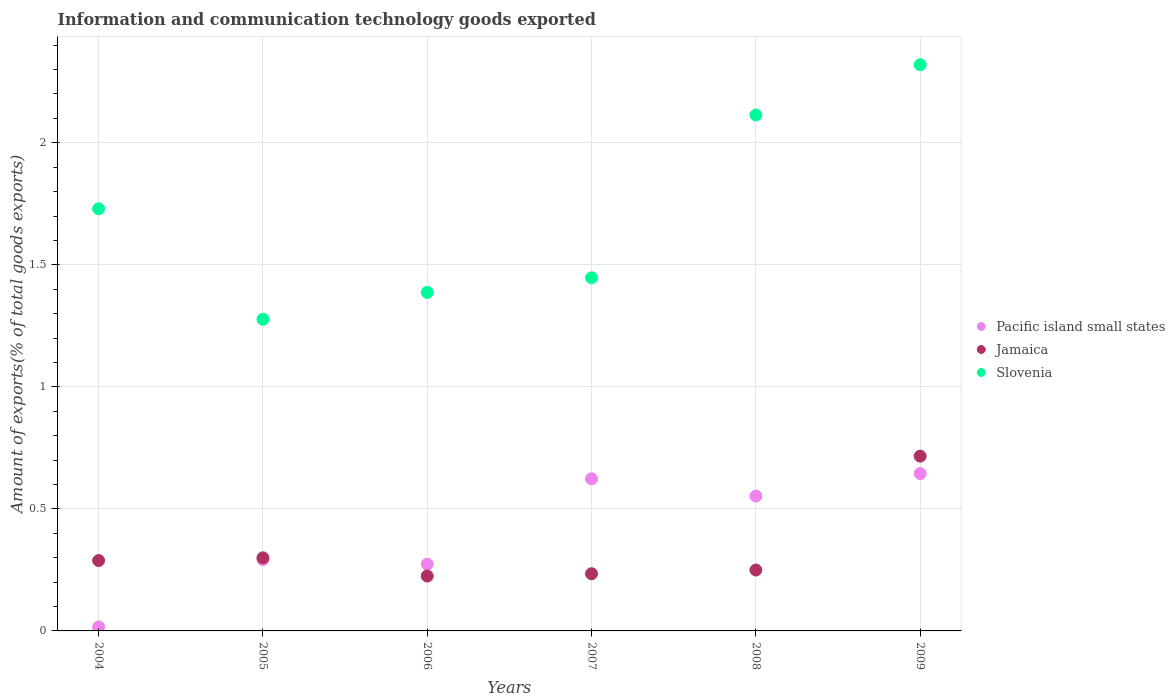What is the amount of goods exported in Pacific island small states in 2007?
Provide a short and direct response. 0.62. Across all years, what is the maximum amount of goods exported in Slovenia?
Offer a very short reply. 2.32. Across all years, what is the minimum amount of goods exported in Pacific island small states?
Ensure brevity in your answer.  0.02. What is the total amount of goods exported in Slovenia in the graph?
Your answer should be very brief. 10.27. What is the difference between the amount of goods exported in Pacific island small states in 2005 and that in 2008?
Ensure brevity in your answer.  -0.26. What is the difference between the amount of goods exported in Slovenia in 2006 and the amount of goods exported in Jamaica in 2004?
Your response must be concise. 1.1. What is the average amount of goods exported in Slovenia per year?
Ensure brevity in your answer.  1.71. In the year 2004, what is the difference between the amount of goods exported in Pacific island small states and amount of goods exported in Slovenia?
Offer a very short reply. -1.71. In how many years, is the amount of goods exported in Pacific island small states greater than 0.9 %?
Your response must be concise. 0. What is the ratio of the amount of goods exported in Slovenia in 2007 to that in 2009?
Provide a short and direct response. 0.62. What is the difference between the highest and the second highest amount of goods exported in Slovenia?
Offer a terse response. 0.21. What is the difference between the highest and the lowest amount of goods exported in Pacific island small states?
Provide a succinct answer. 0.63. In how many years, is the amount of goods exported in Slovenia greater than the average amount of goods exported in Slovenia taken over all years?
Keep it short and to the point. 3. Is the amount of goods exported in Slovenia strictly greater than the amount of goods exported in Pacific island small states over the years?
Offer a very short reply. Yes. Is the amount of goods exported in Jamaica strictly less than the amount of goods exported in Slovenia over the years?
Offer a terse response. Yes. How many dotlines are there?
Make the answer very short. 3. How many years are there in the graph?
Provide a short and direct response. 6. What is the difference between two consecutive major ticks on the Y-axis?
Offer a terse response. 0.5. Are the values on the major ticks of Y-axis written in scientific E-notation?
Your response must be concise. No. What is the title of the graph?
Keep it short and to the point. Information and communication technology goods exported. What is the label or title of the X-axis?
Provide a succinct answer. Years. What is the label or title of the Y-axis?
Provide a short and direct response. Amount of exports(% of total goods exports). What is the Amount of exports(% of total goods exports) of Pacific island small states in 2004?
Your answer should be very brief. 0.02. What is the Amount of exports(% of total goods exports) in Jamaica in 2004?
Keep it short and to the point. 0.29. What is the Amount of exports(% of total goods exports) of Slovenia in 2004?
Your answer should be compact. 1.73. What is the Amount of exports(% of total goods exports) in Pacific island small states in 2005?
Ensure brevity in your answer.  0.29. What is the Amount of exports(% of total goods exports) of Jamaica in 2005?
Give a very brief answer. 0.3. What is the Amount of exports(% of total goods exports) of Slovenia in 2005?
Provide a succinct answer. 1.28. What is the Amount of exports(% of total goods exports) of Pacific island small states in 2006?
Give a very brief answer. 0.27. What is the Amount of exports(% of total goods exports) of Jamaica in 2006?
Offer a terse response. 0.22. What is the Amount of exports(% of total goods exports) of Slovenia in 2006?
Make the answer very short. 1.39. What is the Amount of exports(% of total goods exports) of Pacific island small states in 2007?
Provide a short and direct response. 0.62. What is the Amount of exports(% of total goods exports) in Jamaica in 2007?
Ensure brevity in your answer.  0.23. What is the Amount of exports(% of total goods exports) in Slovenia in 2007?
Your answer should be compact. 1.45. What is the Amount of exports(% of total goods exports) in Pacific island small states in 2008?
Offer a very short reply. 0.55. What is the Amount of exports(% of total goods exports) in Jamaica in 2008?
Provide a short and direct response. 0.25. What is the Amount of exports(% of total goods exports) in Slovenia in 2008?
Offer a very short reply. 2.11. What is the Amount of exports(% of total goods exports) of Pacific island small states in 2009?
Offer a very short reply. 0.64. What is the Amount of exports(% of total goods exports) in Jamaica in 2009?
Give a very brief answer. 0.72. What is the Amount of exports(% of total goods exports) in Slovenia in 2009?
Provide a short and direct response. 2.32. Across all years, what is the maximum Amount of exports(% of total goods exports) of Pacific island small states?
Offer a terse response. 0.64. Across all years, what is the maximum Amount of exports(% of total goods exports) in Jamaica?
Offer a very short reply. 0.72. Across all years, what is the maximum Amount of exports(% of total goods exports) in Slovenia?
Your answer should be compact. 2.32. Across all years, what is the minimum Amount of exports(% of total goods exports) in Pacific island small states?
Offer a terse response. 0.02. Across all years, what is the minimum Amount of exports(% of total goods exports) of Jamaica?
Offer a very short reply. 0.22. Across all years, what is the minimum Amount of exports(% of total goods exports) of Slovenia?
Offer a terse response. 1.28. What is the total Amount of exports(% of total goods exports) of Pacific island small states in the graph?
Keep it short and to the point. 2.4. What is the total Amount of exports(% of total goods exports) of Jamaica in the graph?
Provide a succinct answer. 2.01. What is the total Amount of exports(% of total goods exports) of Slovenia in the graph?
Offer a very short reply. 10.27. What is the difference between the Amount of exports(% of total goods exports) in Pacific island small states in 2004 and that in 2005?
Make the answer very short. -0.28. What is the difference between the Amount of exports(% of total goods exports) of Jamaica in 2004 and that in 2005?
Make the answer very short. -0.01. What is the difference between the Amount of exports(% of total goods exports) in Slovenia in 2004 and that in 2005?
Ensure brevity in your answer.  0.45. What is the difference between the Amount of exports(% of total goods exports) in Pacific island small states in 2004 and that in 2006?
Your response must be concise. -0.26. What is the difference between the Amount of exports(% of total goods exports) of Jamaica in 2004 and that in 2006?
Offer a terse response. 0.06. What is the difference between the Amount of exports(% of total goods exports) of Slovenia in 2004 and that in 2006?
Offer a terse response. 0.34. What is the difference between the Amount of exports(% of total goods exports) of Pacific island small states in 2004 and that in 2007?
Your response must be concise. -0.61. What is the difference between the Amount of exports(% of total goods exports) of Jamaica in 2004 and that in 2007?
Offer a terse response. 0.05. What is the difference between the Amount of exports(% of total goods exports) of Slovenia in 2004 and that in 2007?
Provide a succinct answer. 0.28. What is the difference between the Amount of exports(% of total goods exports) of Pacific island small states in 2004 and that in 2008?
Give a very brief answer. -0.54. What is the difference between the Amount of exports(% of total goods exports) in Jamaica in 2004 and that in 2008?
Your answer should be very brief. 0.04. What is the difference between the Amount of exports(% of total goods exports) in Slovenia in 2004 and that in 2008?
Provide a short and direct response. -0.38. What is the difference between the Amount of exports(% of total goods exports) of Pacific island small states in 2004 and that in 2009?
Keep it short and to the point. -0.63. What is the difference between the Amount of exports(% of total goods exports) in Jamaica in 2004 and that in 2009?
Keep it short and to the point. -0.43. What is the difference between the Amount of exports(% of total goods exports) of Slovenia in 2004 and that in 2009?
Offer a terse response. -0.59. What is the difference between the Amount of exports(% of total goods exports) in Pacific island small states in 2005 and that in 2006?
Make the answer very short. 0.02. What is the difference between the Amount of exports(% of total goods exports) of Jamaica in 2005 and that in 2006?
Ensure brevity in your answer.  0.07. What is the difference between the Amount of exports(% of total goods exports) of Slovenia in 2005 and that in 2006?
Your answer should be compact. -0.11. What is the difference between the Amount of exports(% of total goods exports) in Pacific island small states in 2005 and that in 2007?
Keep it short and to the point. -0.33. What is the difference between the Amount of exports(% of total goods exports) in Jamaica in 2005 and that in 2007?
Ensure brevity in your answer.  0.07. What is the difference between the Amount of exports(% of total goods exports) in Slovenia in 2005 and that in 2007?
Provide a short and direct response. -0.17. What is the difference between the Amount of exports(% of total goods exports) of Pacific island small states in 2005 and that in 2008?
Your answer should be compact. -0.26. What is the difference between the Amount of exports(% of total goods exports) of Slovenia in 2005 and that in 2008?
Make the answer very short. -0.84. What is the difference between the Amount of exports(% of total goods exports) of Pacific island small states in 2005 and that in 2009?
Provide a short and direct response. -0.35. What is the difference between the Amount of exports(% of total goods exports) of Jamaica in 2005 and that in 2009?
Make the answer very short. -0.42. What is the difference between the Amount of exports(% of total goods exports) of Slovenia in 2005 and that in 2009?
Offer a very short reply. -1.04. What is the difference between the Amount of exports(% of total goods exports) in Pacific island small states in 2006 and that in 2007?
Provide a succinct answer. -0.35. What is the difference between the Amount of exports(% of total goods exports) in Jamaica in 2006 and that in 2007?
Make the answer very short. -0.01. What is the difference between the Amount of exports(% of total goods exports) of Slovenia in 2006 and that in 2007?
Your answer should be very brief. -0.06. What is the difference between the Amount of exports(% of total goods exports) in Pacific island small states in 2006 and that in 2008?
Your response must be concise. -0.28. What is the difference between the Amount of exports(% of total goods exports) in Jamaica in 2006 and that in 2008?
Keep it short and to the point. -0.02. What is the difference between the Amount of exports(% of total goods exports) of Slovenia in 2006 and that in 2008?
Ensure brevity in your answer.  -0.73. What is the difference between the Amount of exports(% of total goods exports) in Pacific island small states in 2006 and that in 2009?
Make the answer very short. -0.37. What is the difference between the Amount of exports(% of total goods exports) of Jamaica in 2006 and that in 2009?
Provide a succinct answer. -0.49. What is the difference between the Amount of exports(% of total goods exports) in Slovenia in 2006 and that in 2009?
Ensure brevity in your answer.  -0.93. What is the difference between the Amount of exports(% of total goods exports) of Pacific island small states in 2007 and that in 2008?
Provide a short and direct response. 0.07. What is the difference between the Amount of exports(% of total goods exports) in Jamaica in 2007 and that in 2008?
Make the answer very short. -0.02. What is the difference between the Amount of exports(% of total goods exports) in Slovenia in 2007 and that in 2008?
Your answer should be compact. -0.67. What is the difference between the Amount of exports(% of total goods exports) in Pacific island small states in 2007 and that in 2009?
Your answer should be compact. -0.02. What is the difference between the Amount of exports(% of total goods exports) of Jamaica in 2007 and that in 2009?
Make the answer very short. -0.48. What is the difference between the Amount of exports(% of total goods exports) in Slovenia in 2007 and that in 2009?
Make the answer very short. -0.87. What is the difference between the Amount of exports(% of total goods exports) of Pacific island small states in 2008 and that in 2009?
Make the answer very short. -0.09. What is the difference between the Amount of exports(% of total goods exports) of Jamaica in 2008 and that in 2009?
Keep it short and to the point. -0.47. What is the difference between the Amount of exports(% of total goods exports) in Slovenia in 2008 and that in 2009?
Keep it short and to the point. -0.21. What is the difference between the Amount of exports(% of total goods exports) in Pacific island small states in 2004 and the Amount of exports(% of total goods exports) in Jamaica in 2005?
Ensure brevity in your answer.  -0.28. What is the difference between the Amount of exports(% of total goods exports) of Pacific island small states in 2004 and the Amount of exports(% of total goods exports) of Slovenia in 2005?
Provide a short and direct response. -1.26. What is the difference between the Amount of exports(% of total goods exports) in Jamaica in 2004 and the Amount of exports(% of total goods exports) in Slovenia in 2005?
Offer a terse response. -0.99. What is the difference between the Amount of exports(% of total goods exports) of Pacific island small states in 2004 and the Amount of exports(% of total goods exports) of Jamaica in 2006?
Your answer should be compact. -0.21. What is the difference between the Amount of exports(% of total goods exports) in Pacific island small states in 2004 and the Amount of exports(% of total goods exports) in Slovenia in 2006?
Provide a succinct answer. -1.37. What is the difference between the Amount of exports(% of total goods exports) of Jamaica in 2004 and the Amount of exports(% of total goods exports) of Slovenia in 2006?
Offer a very short reply. -1.1. What is the difference between the Amount of exports(% of total goods exports) in Pacific island small states in 2004 and the Amount of exports(% of total goods exports) in Jamaica in 2007?
Your answer should be very brief. -0.22. What is the difference between the Amount of exports(% of total goods exports) in Pacific island small states in 2004 and the Amount of exports(% of total goods exports) in Slovenia in 2007?
Make the answer very short. -1.43. What is the difference between the Amount of exports(% of total goods exports) in Jamaica in 2004 and the Amount of exports(% of total goods exports) in Slovenia in 2007?
Keep it short and to the point. -1.16. What is the difference between the Amount of exports(% of total goods exports) in Pacific island small states in 2004 and the Amount of exports(% of total goods exports) in Jamaica in 2008?
Your response must be concise. -0.23. What is the difference between the Amount of exports(% of total goods exports) in Pacific island small states in 2004 and the Amount of exports(% of total goods exports) in Slovenia in 2008?
Your response must be concise. -2.1. What is the difference between the Amount of exports(% of total goods exports) in Jamaica in 2004 and the Amount of exports(% of total goods exports) in Slovenia in 2008?
Make the answer very short. -1.83. What is the difference between the Amount of exports(% of total goods exports) of Pacific island small states in 2004 and the Amount of exports(% of total goods exports) of Slovenia in 2009?
Your response must be concise. -2.3. What is the difference between the Amount of exports(% of total goods exports) of Jamaica in 2004 and the Amount of exports(% of total goods exports) of Slovenia in 2009?
Ensure brevity in your answer.  -2.03. What is the difference between the Amount of exports(% of total goods exports) of Pacific island small states in 2005 and the Amount of exports(% of total goods exports) of Jamaica in 2006?
Ensure brevity in your answer.  0.07. What is the difference between the Amount of exports(% of total goods exports) of Pacific island small states in 2005 and the Amount of exports(% of total goods exports) of Slovenia in 2006?
Provide a short and direct response. -1.09. What is the difference between the Amount of exports(% of total goods exports) of Jamaica in 2005 and the Amount of exports(% of total goods exports) of Slovenia in 2006?
Provide a short and direct response. -1.09. What is the difference between the Amount of exports(% of total goods exports) of Pacific island small states in 2005 and the Amount of exports(% of total goods exports) of Jamaica in 2007?
Your answer should be very brief. 0.06. What is the difference between the Amount of exports(% of total goods exports) of Pacific island small states in 2005 and the Amount of exports(% of total goods exports) of Slovenia in 2007?
Offer a very short reply. -1.15. What is the difference between the Amount of exports(% of total goods exports) of Jamaica in 2005 and the Amount of exports(% of total goods exports) of Slovenia in 2007?
Make the answer very short. -1.15. What is the difference between the Amount of exports(% of total goods exports) in Pacific island small states in 2005 and the Amount of exports(% of total goods exports) in Jamaica in 2008?
Offer a terse response. 0.04. What is the difference between the Amount of exports(% of total goods exports) of Pacific island small states in 2005 and the Amount of exports(% of total goods exports) of Slovenia in 2008?
Your answer should be compact. -1.82. What is the difference between the Amount of exports(% of total goods exports) in Jamaica in 2005 and the Amount of exports(% of total goods exports) in Slovenia in 2008?
Your answer should be compact. -1.81. What is the difference between the Amount of exports(% of total goods exports) of Pacific island small states in 2005 and the Amount of exports(% of total goods exports) of Jamaica in 2009?
Your response must be concise. -0.42. What is the difference between the Amount of exports(% of total goods exports) of Pacific island small states in 2005 and the Amount of exports(% of total goods exports) of Slovenia in 2009?
Keep it short and to the point. -2.03. What is the difference between the Amount of exports(% of total goods exports) in Jamaica in 2005 and the Amount of exports(% of total goods exports) in Slovenia in 2009?
Your answer should be very brief. -2.02. What is the difference between the Amount of exports(% of total goods exports) of Pacific island small states in 2006 and the Amount of exports(% of total goods exports) of Jamaica in 2007?
Your response must be concise. 0.04. What is the difference between the Amount of exports(% of total goods exports) of Pacific island small states in 2006 and the Amount of exports(% of total goods exports) of Slovenia in 2007?
Provide a succinct answer. -1.17. What is the difference between the Amount of exports(% of total goods exports) of Jamaica in 2006 and the Amount of exports(% of total goods exports) of Slovenia in 2007?
Offer a terse response. -1.22. What is the difference between the Amount of exports(% of total goods exports) in Pacific island small states in 2006 and the Amount of exports(% of total goods exports) in Jamaica in 2008?
Offer a terse response. 0.02. What is the difference between the Amount of exports(% of total goods exports) of Pacific island small states in 2006 and the Amount of exports(% of total goods exports) of Slovenia in 2008?
Offer a very short reply. -1.84. What is the difference between the Amount of exports(% of total goods exports) of Jamaica in 2006 and the Amount of exports(% of total goods exports) of Slovenia in 2008?
Give a very brief answer. -1.89. What is the difference between the Amount of exports(% of total goods exports) of Pacific island small states in 2006 and the Amount of exports(% of total goods exports) of Jamaica in 2009?
Your answer should be very brief. -0.44. What is the difference between the Amount of exports(% of total goods exports) of Pacific island small states in 2006 and the Amount of exports(% of total goods exports) of Slovenia in 2009?
Provide a succinct answer. -2.05. What is the difference between the Amount of exports(% of total goods exports) of Jamaica in 2006 and the Amount of exports(% of total goods exports) of Slovenia in 2009?
Provide a short and direct response. -2.1. What is the difference between the Amount of exports(% of total goods exports) in Pacific island small states in 2007 and the Amount of exports(% of total goods exports) in Jamaica in 2008?
Give a very brief answer. 0.37. What is the difference between the Amount of exports(% of total goods exports) of Pacific island small states in 2007 and the Amount of exports(% of total goods exports) of Slovenia in 2008?
Provide a succinct answer. -1.49. What is the difference between the Amount of exports(% of total goods exports) of Jamaica in 2007 and the Amount of exports(% of total goods exports) of Slovenia in 2008?
Provide a short and direct response. -1.88. What is the difference between the Amount of exports(% of total goods exports) of Pacific island small states in 2007 and the Amount of exports(% of total goods exports) of Jamaica in 2009?
Offer a terse response. -0.09. What is the difference between the Amount of exports(% of total goods exports) of Pacific island small states in 2007 and the Amount of exports(% of total goods exports) of Slovenia in 2009?
Keep it short and to the point. -1.7. What is the difference between the Amount of exports(% of total goods exports) of Jamaica in 2007 and the Amount of exports(% of total goods exports) of Slovenia in 2009?
Your answer should be very brief. -2.09. What is the difference between the Amount of exports(% of total goods exports) in Pacific island small states in 2008 and the Amount of exports(% of total goods exports) in Jamaica in 2009?
Your answer should be compact. -0.16. What is the difference between the Amount of exports(% of total goods exports) of Pacific island small states in 2008 and the Amount of exports(% of total goods exports) of Slovenia in 2009?
Your response must be concise. -1.77. What is the difference between the Amount of exports(% of total goods exports) of Jamaica in 2008 and the Amount of exports(% of total goods exports) of Slovenia in 2009?
Offer a very short reply. -2.07. What is the average Amount of exports(% of total goods exports) of Pacific island small states per year?
Make the answer very short. 0.4. What is the average Amount of exports(% of total goods exports) of Jamaica per year?
Offer a very short reply. 0.34. What is the average Amount of exports(% of total goods exports) of Slovenia per year?
Offer a very short reply. 1.71. In the year 2004, what is the difference between the Amount of exports(% of total goods exports) in Pacific island small states and Amount of exports(% of total goods exports) in Jamaica?
Make the answer very short. -0.27. In the year 2004, what is the difference between the Amount of exports(% of total goods exports) in Pacific island small states and Amount of exports(% of total goods exports) in Slovenia?
Give a very brief answer. -1.71. In the year 2004, what is the difference between the Amount of exports(% of total goods exports) in Jamaica and Amount of exports(% of total goods exports) in Slovenia?
Ensure brevity in your answer.  -1.44. In the year 2005, what is the difference between the Amount of exports(% of total goods exports) of Pacific island small states and Amount of exports(% of total goods exports) of Jamaica?
Keep it short and to the point. -0.01. In the year 2005, what is the difference between the Amount of exports(% of total goods exports) in Pacific island small states and Amount of exports(% of total goods exports) in Slovenia?
Offer a very short reply. -0.98. In the year 2005, what is the difference between the Amount of exports(% of total goods exports) in Jamaica and Amount of exports(% of total goods exports) in Slovenia?
Your answer should be compact. -0.98. In the year 2006, what is the difference between the Amount of exports(% of total goods exports) of Pacific island small states and Amount of exports(% of total goods exports) of Jamaica?
Provide a short and direct response. 0.05. In the year 2006, what is the difference between the Amount of exports(% of total goods exports) of Pacific island small states and Amount of exports(% of total goods exports) of Slovenia?
Provide a succinct answer. -1.11. In the year 2006, what is the difference between the Amount of exports(% of total goods exports) in Jamaica and Amount of exports(% of total goods exports) in Slovenia?
Provide a succinct answer. -1.16. In the year 2007, what is the difference between the Amount of exports(% of total goods exports) in Pacific island small states and Amount of exports(% of total goods exports) in Jamaica?
Offer a very short reply. 0.39. In the year 2007, what is the difference between the Amount of exports(% of total goods exports) of Pacific island small states and Amount of exports(% of total goods exports) of Slovenia?
Your answer should be compact. -0.82. In the year 2007, what is the difference between the Amount of exports(% of total goods exports) of Jamaica and Amount of exports(% of total goods exports) of Slovenia?
Provide a succinct answer. -1.21. In the year 2008, what is the difference between the Amount of exports(% of total goods exports) of Pacific island small states and Amount of exports(% of total goods exports) of Jamaica?
Provide a succinct answer. 0.3. In the year 2008, what is the difference between the Amount of exports(% of total goods exports) in Pacific island small states and Amount of exports(% of total goods exports) in Slovenia?
Your response must be concise. -1.56. In the year 2008, what is the difference between the Amount of exports(% of total goods exports) in Jamaica and Amount of exports(% of total goods exports) in Slovenia?
Provide a short and direct response. -1.86. In the year 2009, what is the difference between the Amount of exports(% of total goods exports) of Pacific island small states and Amount of exports(% of total goods exports) of Jamaica?
Keep it short and to the point. -0.07. In the year 2009, what is the difference between the Amount of exports(% of total goods exports) of Pacific island small states and Amount of exports(% of total goods exports) of Slovenia?
Your answer should be very brief. -1.68. In the year 2009, what is the difference between the Amount of exports(% of total goods exports) in Jamaica and Amount of exports(% of total goods exports) in Slovenia?
Give a very brief answer. -1.6. What is the ratio of the Amount of exports(% of total goods exports) of Pacific island small states in 2004 to that in 2005?
Give a very brief answer. 0.06. What is the ratio of the Amount of exports(% of total goods exports) in Jamaica in 2004 to that in 2005?
Your answer should be very brief. 0.96. What is the ratio of the Amount of exports(% of total goods exports) in Slovenia in 2004 to that in 2005?
Your answer should be very brief. 1.35. What is the ratio of the Amount of exports(% of total goods exports) in Pacific island small states in 2004 to that in 2006?
Provide a succinct answer. 0.06. What is the ratio of the Amount of exports(% of total goods exports) in Jamaica in 2004 to that in 2006?
Your response must be concise. 1.28. What is the ratio of the Amount of exports(% of total goods exports) of Slovenia in 2004 to that in 2006?
Your answer should be compact. 1.25. What is the ratio of the Amount of exports(% of total goods exports) of Pacific island small states in 2004 to that in 2007?
Make the answer very short. 0.03. What is the ratio of the Amount of exports(% of total goods exports) in Jamaica in 2004 to that in 2007?
Make the answer very short. 1.23. What is the ratio of the Amount of exports(% of total goods exports) of Slovenia in 2004 to that in 2007?
Provide a short and direct response. 1.2. What is the ratio of the Amount of exports(% of total goods exports) in Pacific island small states in 2004 to that in 2008?
Your answer should be very brief. 0.03. What is the ratio of the Amount of exports(% of total goods exports) in Jamaica in 2004 to that in 2008?
Keep it short and to the point. 1.16. What is the ratio of the Amount of exports(% of total goods exports) of Slovenia in 2004 to that in 2008?
Ensure brevity in your answer.  0.82. What is the ratio of the Amount of exports(% of total goods exports) of Pacific island small states in 2004 to that in 2009?
Make the answer very short. 0.03. What is the ratio of the Amount of exports(% of total goods exports) of Jamaica in 2004 to that in 2009?
Ensure brevity in your answer.  0.4. What is the ratio of the Amount of exports(% of total goods exports) of Slovenia in 2004 to that in 2009?
Provide a short and direct response. 0.75. What is the ratio of the Amount of exports(% of total goods exports) of Pacific island small states in 2005 to that in 2006?
Offer a very short reply. 1.07. What is the ratio of the Amount of exports(% of total goods exports) in Jamaica in 2005 to that in 2006?
Your answer should be very brief. 1.33. What is the ratio of the Amount of exports(% of total goods exports) of Slovenia in 2005 to that in 2006?
Make the answer very short. 0.92. What is the ratio of the Amount of exports(% of total goods exports) in Pacific island small states in 2005 to that in 2007?
Keep it short and to the point. 0.47. What is the ratio of the Amount of exports(% of total goods exports) in Jamaica in 2005 to that in 2007?
Make the answer very short. 1.28. What is the ratio of the Amount of exports(% of total goods exports) of Slovenia in 2005 to that in 2007?
Offer a terse response. 0.88. What is the ratio of the Amount of exports(% of total goods exports) of Pacific island small states in 2005 to that in 2008?
Ensure brevity in your answer.  0.53. What is the ratio of the Amount of exports(% of total goods exports) in Jamaica in 2005 to that in 2008?
Provide a succinct answer. 1.2. What is the ratio of the Amount of exports(% of total goods exports) of Slovenia in 2005 to that in 2008?
Provide a short and direct response. 0.6. What is the ratio of the Amount of exports(% of total goods exports) in Pacific island small states in 2005 to that in 2009?
Provide a succinct answer. 0.45. What is the ratio of the Amount of exports(% of total goods exports) in Jamaica in 2005 to that in 2009?
Keep it short and to the point. 0.42. What is the ratio of the Amount of exports(% of total goods exports) in Slovenia in 2005 to that in 2009?
Provide a short and direct response. 0.55. What is the ratio of the Amount of exports(% of total goods exports) of Pacific island small states in 2006 to that in 2007?
Give a very brief answer. 0.44. What is the ratio of the Amount of exports(% of total goods exports) in Jamaica in 2006 to that in 2007?
Your response must be concise. 0.96. What is the ratio of the Amount of exports(% of total goods exports) in Slovenia in 2006 to that in 2007?
Offer a very short reply. 0.96. What is the ratio of the Amount of exports(% of total goods exports) of Pacific island small states in 2006 to that in 2008?
Keep it short and to the point. 0.49. What is the ratio of the Amount of exports(% of total goods exports) of Jamaica in 2006 to that in 2008?
Ensure brevity in your answer.  0.9. What is the ratio of the Amount of exports(% of total goods exports) of Slovenia in 2006 to that in 2008?
Provide a short and direct response. 0.66. What is the ratio of the Amount of exports(% of total goods exports) of Pacific island small states in 2006 to that in 2009?
Make the answer very short. 0.42. What is the ratio of the Amount of exports(% of total goods exports) of Jamaica in 2006 to that in 2009?
Offer a terse response. 0.31. What is the ratio of the Amount of exports(% of total goods exports) of Slovenia in 2006 to that in 2009?
Keep it short and to the point. 0.6. What is the ratio of the Amount of exports(% of total goods exports) in Pacific island small states in 2007 to that in 2008?
Ensure brevity in your answer.  1.13. What is the ratio of the Amount of exports(% of total goods exports) of Jamaica in 2007 to that in 2008?
Keep it short and to the point. 0.94. What is the ratio of the Amount of exports(% of total goods exports) of Slovenia in 2007 to that in 2008?
Offer a terse response. 0.68. What is the ratio of the Amount of exports(% of total goods exports) in Pacific island small states in 2007 to that in 2009?
Keep it short and to the point. 0.97. What is the ratio of the Amount of exports(% of total goods exports) of Jamaica in 2007 to that in 2009?
Provide a short and direct response. 0.33. What is the ratio of the Amount of exports(% of total goods exports) of Slovenia in 2007 to that in 2009?
Your response must be concise. 0.62. What is the ratio of the Amount of exports(% of total goods exports) in Jamaica in 2008 to that in 2009?
Your answer should be compact. 0.35. What is the ratio of the Amount of exports(% of total goods exports) in Slovenia in 2008 to that in 2009?
Give a very brief answer. 0.91. What is the difference between the highest and the second highest Amount of exports(% of total goods exports) of Pacific island small states?
Give a very brief answer. 0.02. What is the difference between the highest and the second highest Amount of exports(% of total goods exports) in Jamaica?
Your response must be concise. 0.42. What is the difference between the highest and the second highest Amount of exports(% of total goods exports) of Slovenia?
Provide a short and direct response. 0.21. What is the difference between the highest and the lowest Amount of exports(% of total goods exports) in Pacific island small states?
Give a very brief answer. 0.63. What is the difference between the highest and the lowest Amount of exports(% of total goods exports) of Jamaica?
Ensure brevity in your answer.  0.49. What is the difference between the highest and the lowest Amount of exports(% of total goods exports) in Slovenia?
Your answer should be very brief. 1.04. 